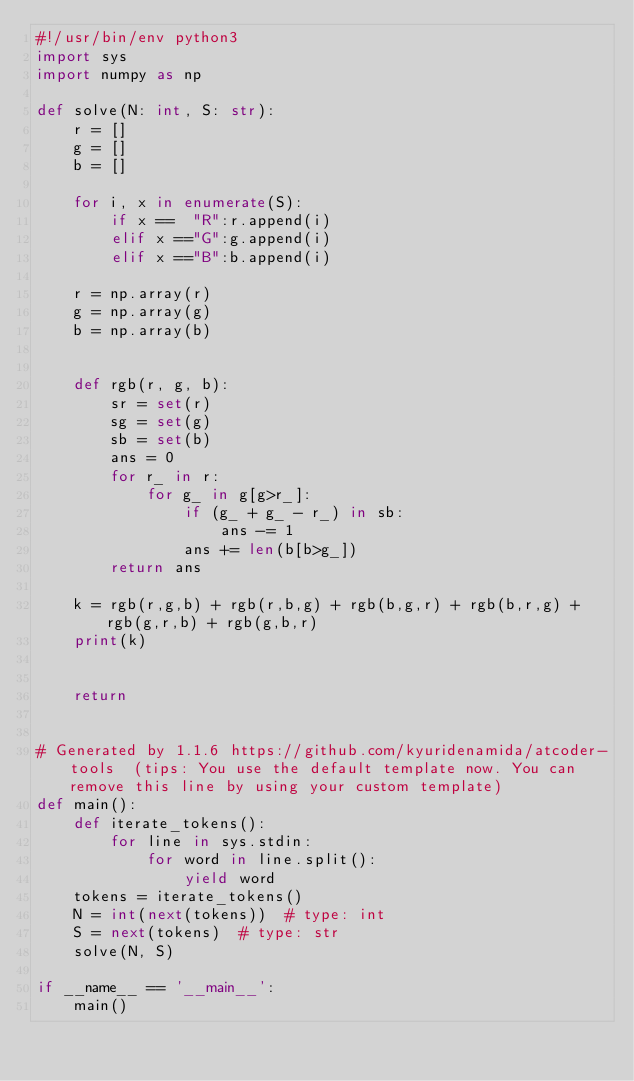Convert code to text. <code><loc_0><loc_0><loc_500><loc_500><_Python_>#!/usr/bin/env python3
import sys
import numpy as np

def solve(N: int, S: str):
    r = []
    g = []
    b = []

    for i, x in enumerate(S):
        if x ==  "R":r.append(i)
        elif x =="G":g.append(i)
        elif x =="B":b.append(i)

    r = np.array(r)
    g = np.array(g)
    b = np.array(b)


    def rgb(r, g, b):
        sr = set(r)
        sg = set(g)
        sb = set(b)
        ans = 0
        for r_ in r:
            for g_ in g[g>r_]:
                if (g_ + g_ - r_) in sb:
                    ans -= 1
                ans += len(b[b>g_])
        return ans

    k = rgb(r,g,b) + rgb(r,b,g) + rgb(b,g,r) + rgb(b,r,g) + rgb(g,r,b) + rgb(g,b,r)
    print(k)


    return


# Generated by 1.1.6 https://github.com/kyuridenamida/atcoder-tools  (tips: You use the default template now. You can remove this line by using your custom template)
def main():
    def iterate_tokens():
        for line in sys.stdin:
            for word in line.split():
                yield word
    tokens = iterate_tokens()
    N = int(next(tokens))  # type: int
    S = next(tokens)  # type: str
    solve(N, S)

if __name__ == '__main__':
    main()
</code> 